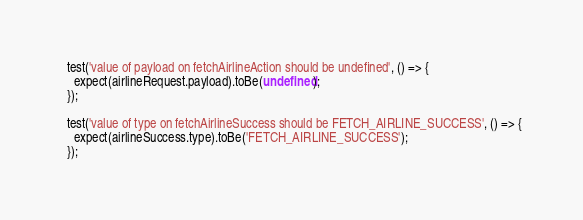<code> <loc_0><loc_0><loc_500><loc_500><_JavaScript_>  test('value of payload on fetchAirlineAction should be undefined', () => {
    expect(airlineRequest.payload).toBe(undefined);
  });

  test('value of type on fetchAirlineSuccess should be FETCH_AIRLINE_SUCCESS', () => {
    expect(airlineSuccess.type).toBe('FETCH_AIRLINE_SUCCESS');
  });
</code> 